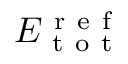Convert formula to latex. <formula><loc_0><loc_0><loc_500><loc_500>E _ { t o t } ^ { r e f }</formula> 